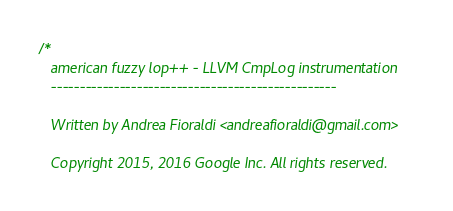Convert code to text. <code><loc_0><loc_0><loc_500><loc_500><_C++_>/*
   american fuzzy lop++ - LLVM CmpLog instrumentation
   --------------------------------------------------

   Written by Andrea Fioraldi <andreafioraldi@gmail.com>

   Copyright 2015, 2016 Google Inc. All rights reserved.</code> 